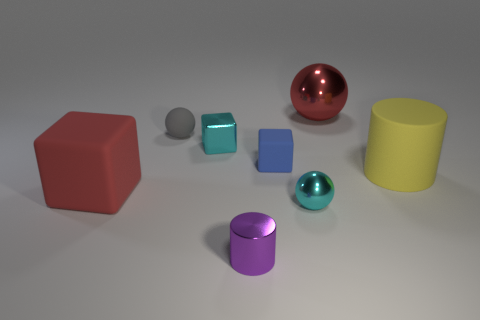How many large rubber objects have the same shape as the small purple metal object?
Provide a succinct answer. 1. What material is the cube that is the same color as the big sphere?
Your answer should be compact. Rubber. Is the small blue thing made of the same material as the large yellow object?
Give a very brief answer. Yes. What number of small blue rubber blocks are on the left side of the small sphere behind the block that is on the right side of the small purple metal cylinder?
Your answer should be very brief. 0. Are there any other big red balls that have the same material as the red ball?
Give a very brief answer. No. What size is the sphere that is the same color as the small shiny block?
Ensure brevity in your answer.  Small. Are there fewer big cubes than cylinders?
Provide a succinct answer. Yes. Is the color of the large matte object that is to the right of the small cyan sphere the same as the large ball?
Provide a short and direct response. No. There is a cylinder that is to the left of the red thing to the right of the small cube to the right of the small purple shiny object; what is it made of?
Your answer should be compact. Metal. Are there any matte objects of the same color as the tiny cylinder?
Offer a very short reply. No. 